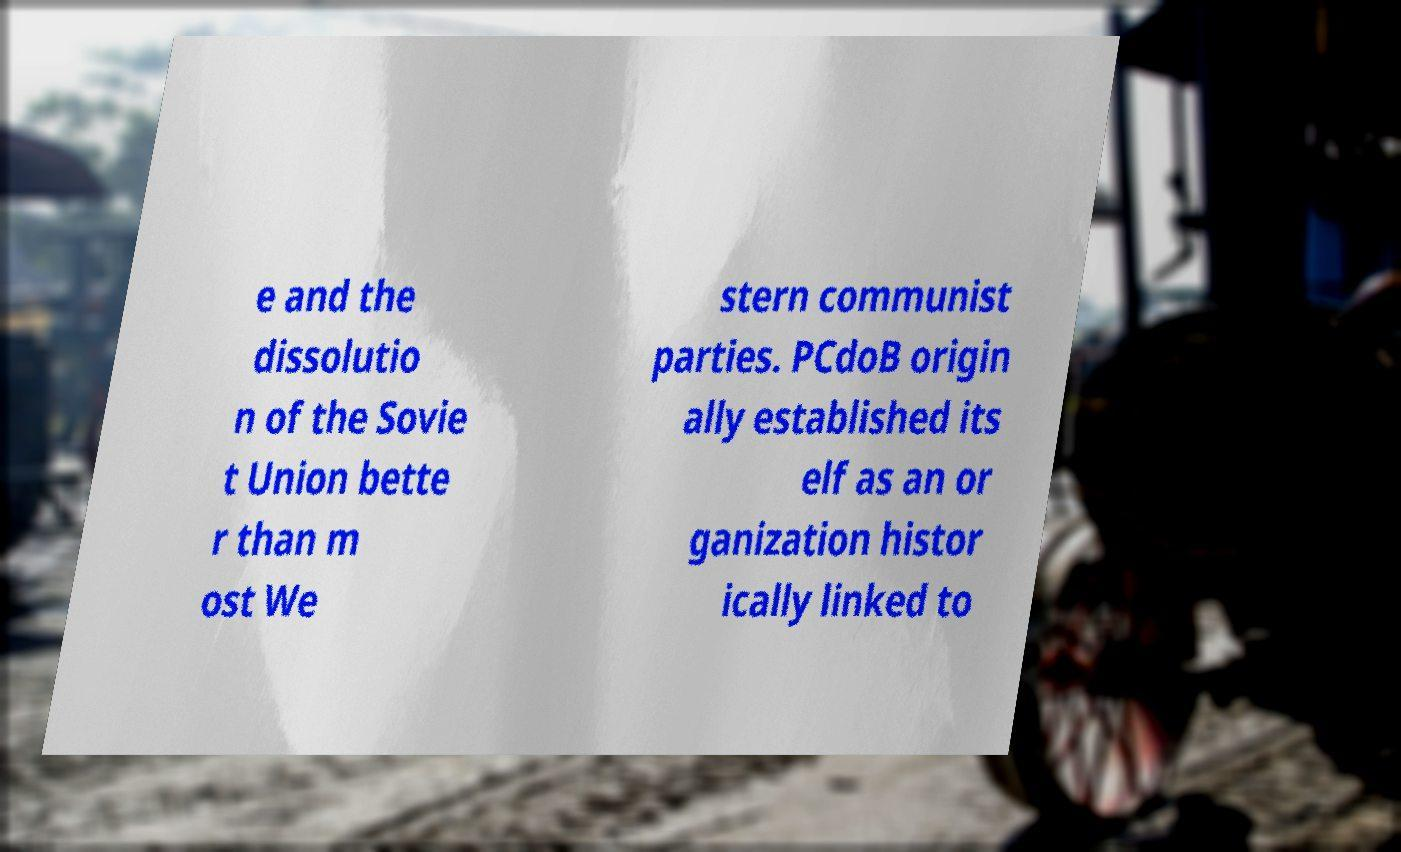Can you read and provide the text displayed in the image?This photo seems to have some interesting text. Can you extract and type it out for me? e and the dissolutio n of the Sovie t Union bette r than m ost We stern communist parties. PCdoB origin ally established its elf as an or ganization histor ically linked to 